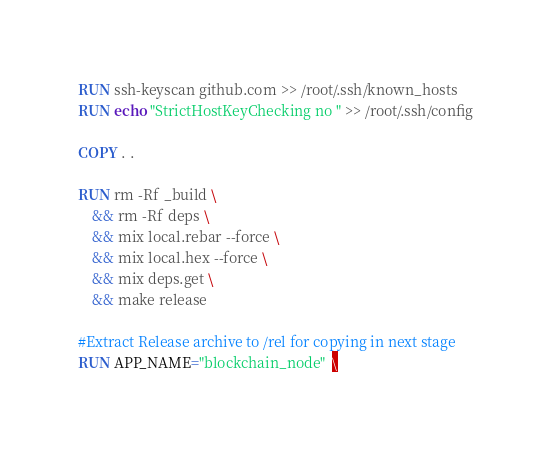<code> <loc_0><loc_0><loc_500><loc_500><_Dockerfile_>RUN ssh-keyscan github.com >> /root/.ssh/known_hosts
RUN echo "StrictHostKeyChecking no " >> /root/.ssh/config

COPY . .

RUN rm -Rf _build \
    && rm -Rf deps \
    && mix local.rebar --force \
    && mix local.hex --force \
    && mix deps.get \
    && make release

#Extract Release archive to /rel for copying in next stage
RUN APP_NAME="blockchain_node"  \</code> 